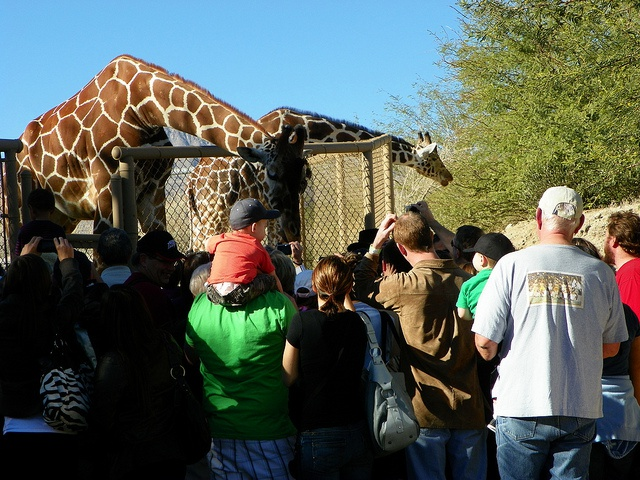Describe the objects in this image and their specific colors. I can see people in lightblue, white, gray, black, and darkgray tones, giraffe in lightblue, black, brown, maroon, and gray tones, people in lightblue, black, tan, and olive tones, people in lightblue, black, purple, and blue tones, and people in lightblue, black, maroon, and tan tones in this image. 